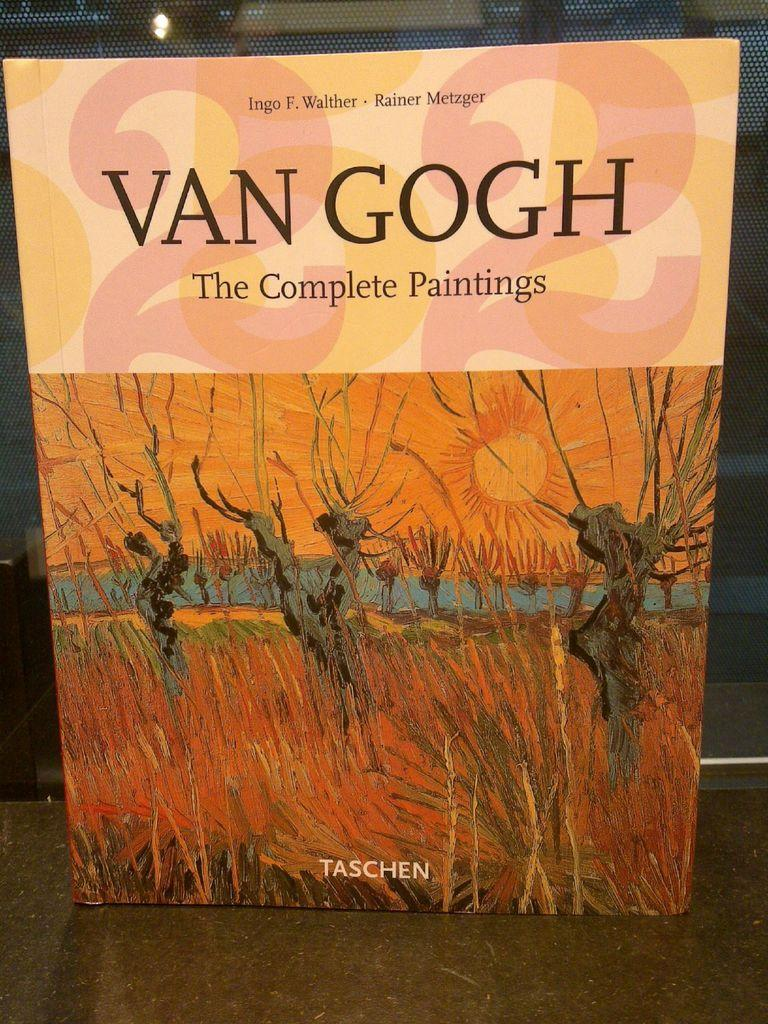Provide a one-sentence caption for the provided image. A book named The Complete Paintings by Van Gogh that is placed upright on a surface. 